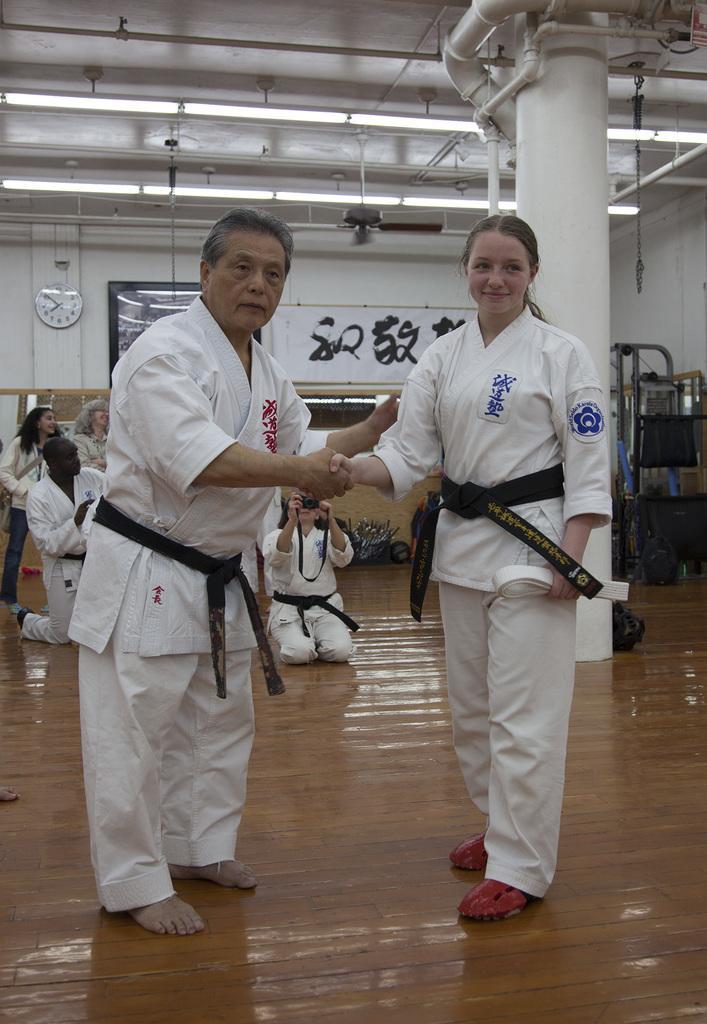Can you describe this image briefly? In this image in the foreground there is one man and one woman standing, and they are wearing uniforms and shaking hands with each other. And in the background there are some people one person is holding a camera and also there is a pillar, clock and some boards and some objects. At the bottom there is floor, and at the top there is ceiling and some lights and pipes. 